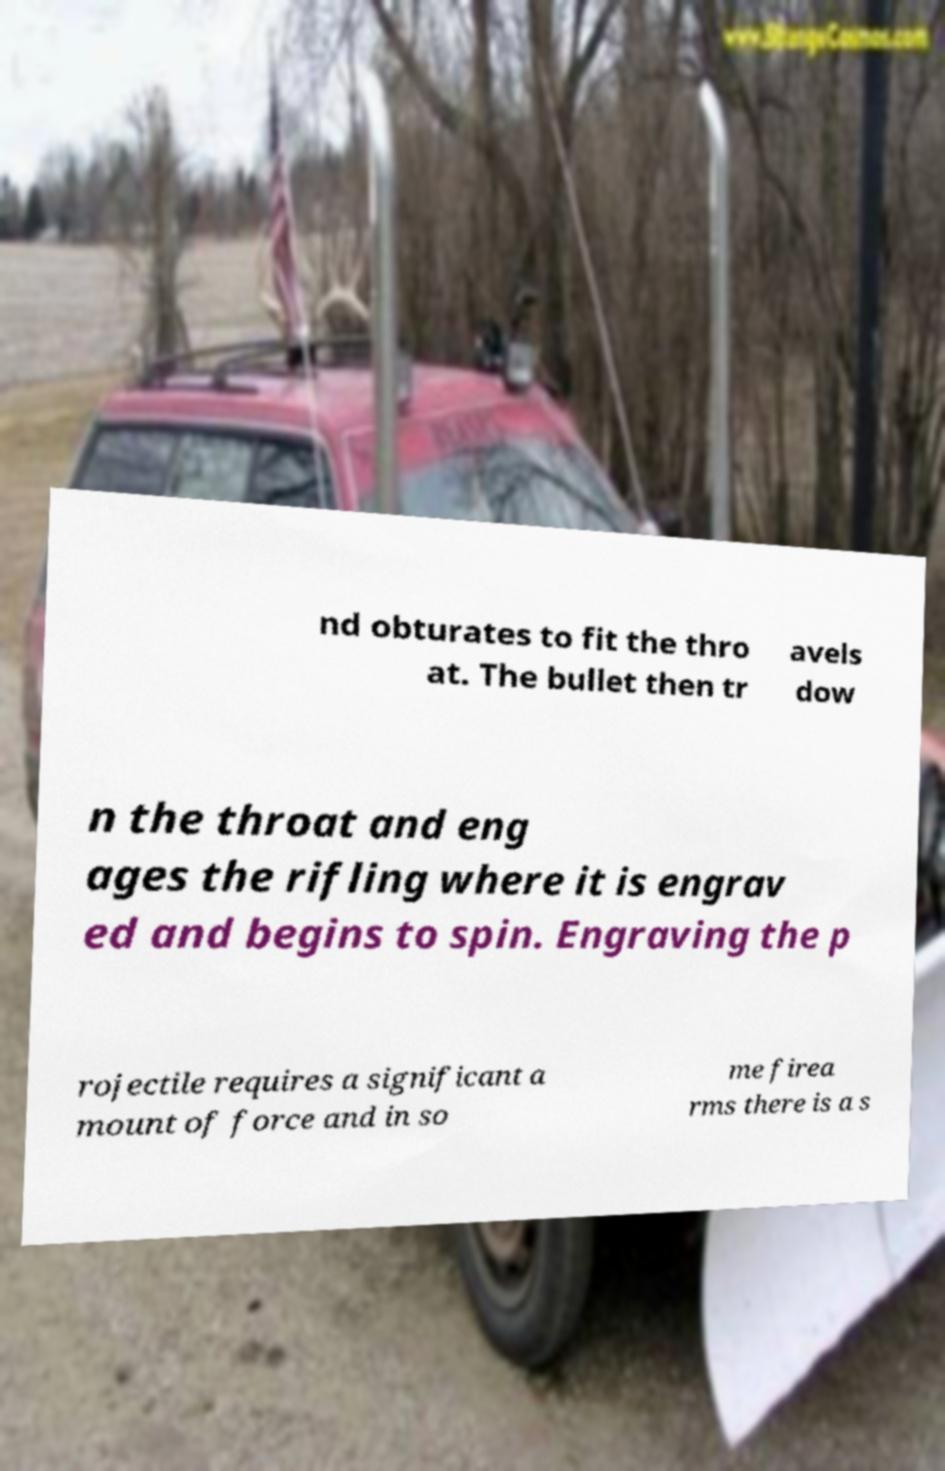There's text embedded in this image that I need extracted. Can you transcribe it verbatim? nd obturates to fit the thro at. The bullet then tr avels dow n the throat and eng ages the rifling where it is engrav ed and begins to spin. Engraving the p rojectile requires a significant a mount of force and in so me firea rms there is a s 